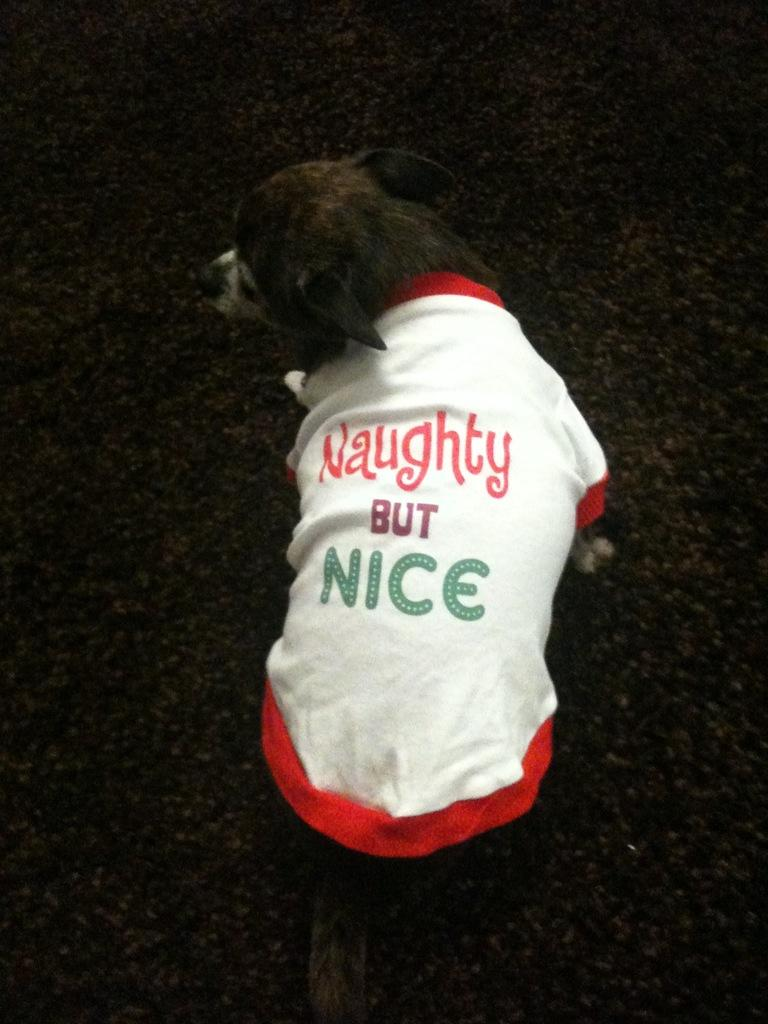What animal is present in the image? There is a dog in the image. What is the dog doing in the image? The dog is standing. What is unique about the dog's appearance in the image? The dog is wearing a dress. What can be read on the dog's dress? There is text on the dog's dress. How does the dog protect itself from the rainstorm in the image? There is no rainstorm present in the image, and therefore no need for the dog to protect itself from one. 